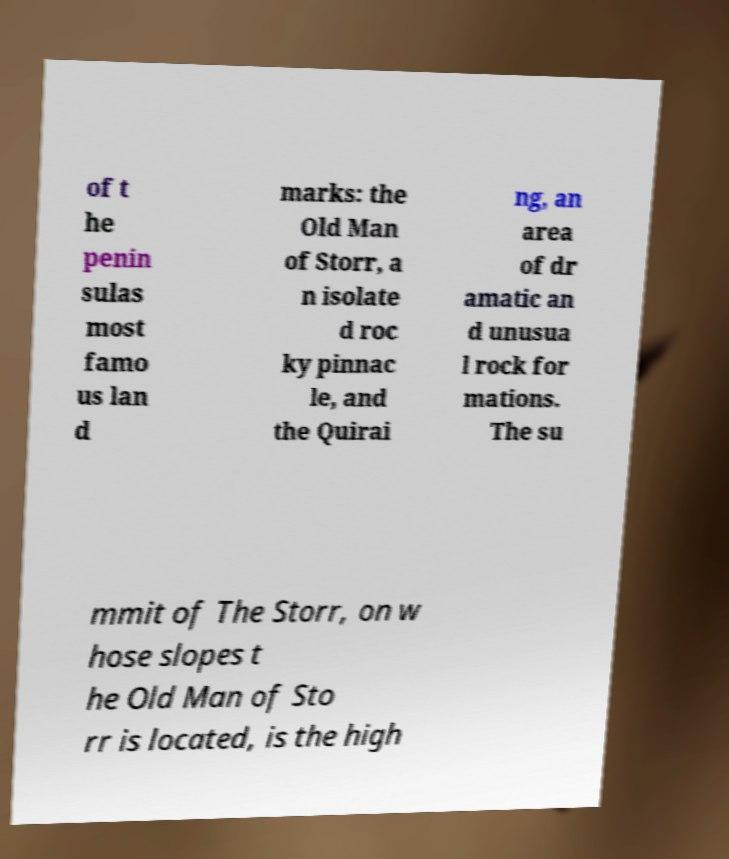Please read and relay the text visible in this image. What does it say? of t he penin sulas most famo us lan d marks: the Old Man of Storr, a n isolate d roc ky pinnac le, and the Quirai ng, an area of dr amatic an d unusua l rock for mations. The su mmit of The Storr, on w hose slopes t he Old Man of Sto rr is located, is the high 